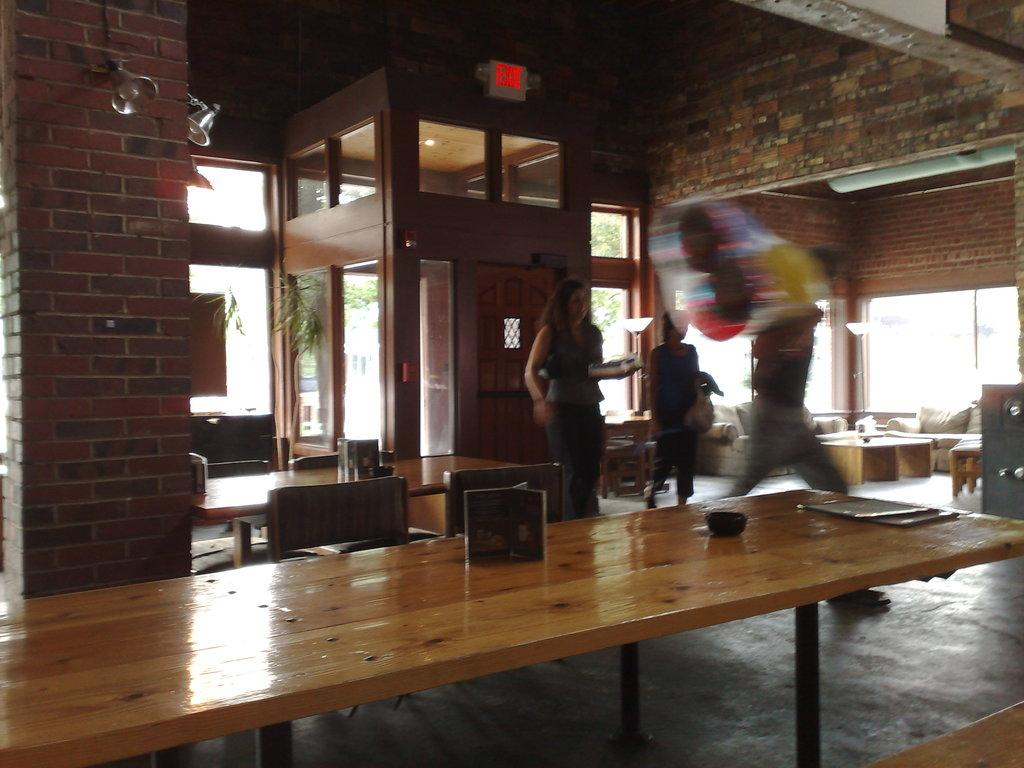What type of furniture is present in the image? There is a table and a chair in the image. How many people are in the image? There are three persons in the image. What type of health advice can be seen on the table in the image? There is no health advice present on the table in the image. What type of structure is the chair in the image made of? The provided facts do not specify the material or structure of the chair. 